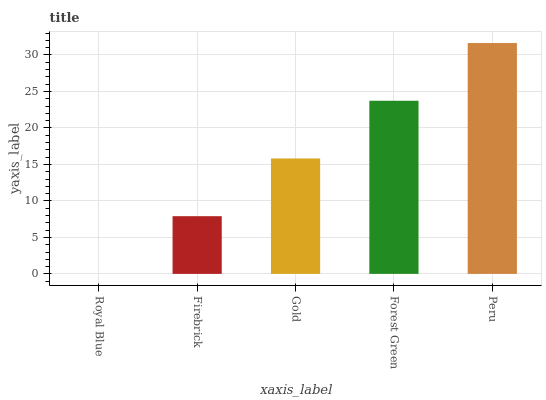Is Peru the maximum?
Answer yes or no. Yes. Is Firebrick the minimum?
Answer yes or no. No. Is Firebrick the maximum?
Answer yes or no. No. Is Firebrick greater than Royal Blue?
Answer yes or no. Yes. Is Royal Blue less than Firebrick?
Answer yes or no. Yes. Is Royal Blue greater than Firebrick?
Answer yes or no. No. Is Firebrick less than Royal Blue?
Answer yes or no. No. Is Gold the high median?
Answer yes or no. Yes. Is Gold the low median?
Answer yes or no. Yes. Is Firebrick the high median?
Answer yes or no. No. Is Forest Green the low median?
Answer yes or no. No. 